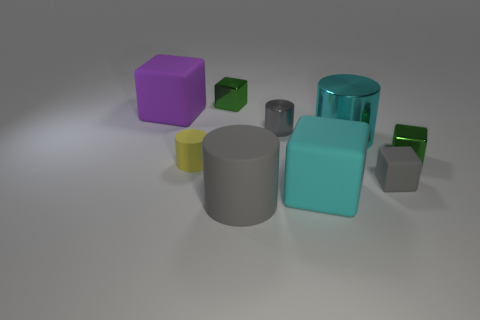Subtract all tiny rubber blocks. How many blocks are left? 4 Subtract all gray blocks. How many blocks are left? 4 Subtract all red cubes. Subtract all gray cylinders. How many cubes are left? 5 Add 1 large cubes. How many objects exist? 10 Subtract all cylinders. How many objects are left? 5 Add 2 small gray blocks. How many small gray blocks exist? 3 Subtract 0 red spheres. How many objects are left? 9 Subtract all yellow shiny balls. Subtract all yellow rubber cylinders. How many objects are left? 8 Add 5 green objects. How many green objects are left? 7 